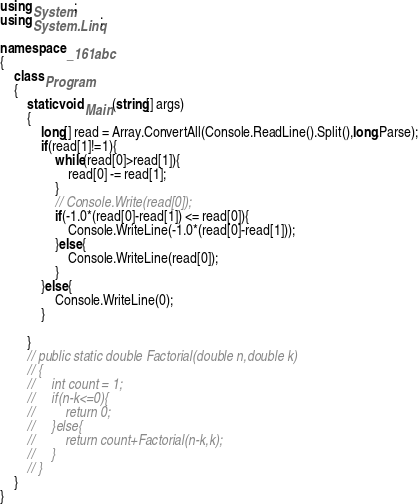<code> <loc_0><loc_0><loc_500><loc_500><_C#_>using System;
using System.Linq;

namespace _161abc
{
    class Program
    {
        static void Main(string[] args)
        {
            long[] read = Array.ConvertAll(Console.ReadLine().Split(),long.Parse);
            if(read[1]!=1){
                while(read[0]>read[1]){
                    read[0] -= read[1];
                }
                // Console.Write(read[0]);
                if(-1.0*(read[0]-read[1]) <= read[0]){
                    Console.WriteLine(-1.0*(read[0]-read[1]));
                }else{
                    Console.WriteLine(read[0]);
                }
            }else{
                Console.WriteLine(0);
            }

        }
        // public static double Factorial(double n,double k)
        // {
        //     int count = 1;
        //     if(n-k<=0){
        //         return 0;
        //     }else{
        //         return count+Factorial(n-k,k);
        //     }   
        // }
    }
}
</code> 